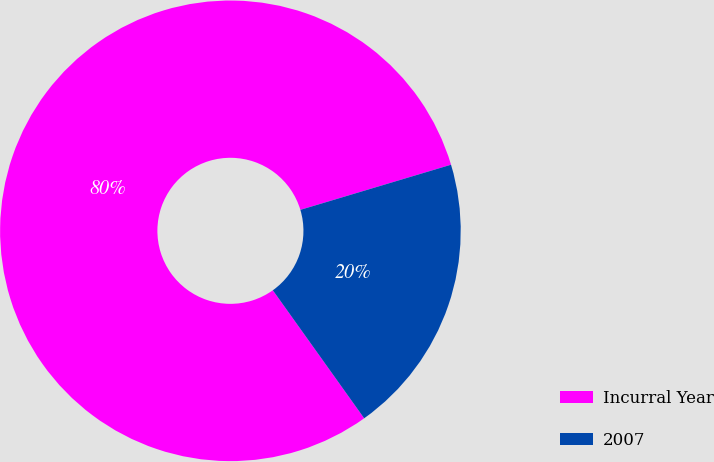<chart> <loc_0><loc_0><loc_500><loc_500><pie_chart><fcel>Incurral Year<fcel>2007<nl><fcel>80.23%<fcel>19.77%<nl></chart> 